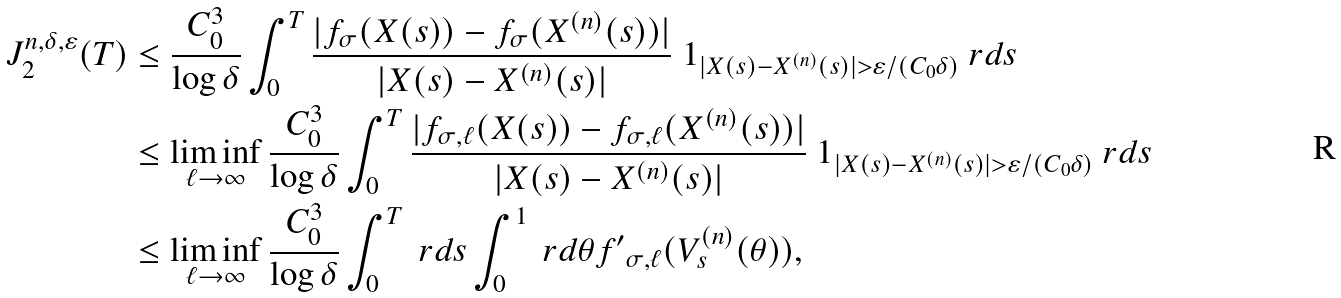<formula> <loc_0><loc_0><loc_500><loc_500>J _ { 2 } ^ { n , \delta , \varepsilon } ( T ) & \leq \frac { C ^ { 3 } _ { 0 } } { \log \delta } \int _ { 0 } ^ { T } \frac { | f _ { \sigma } ( X ( s ) ) - f _ { \sigma } ( X ^ { ( n ) } ( s ) ) | } { | X ( s ) - X ^ { ( n ) } ( s ) | } \ 1 _ { | X ( s ) - X ^ { ( n ) } ( s ) | > \varepsilon / ( C _ { 0 } \delta ) } \ r d s \\ & \leq \liminf _ { \ell \to \infty } \frac { C ^ { 3 } _ { 0 } } { \log \delta } \int _ { 0 } ^ { T } \frac { | f _ { \sigma , \ell } ( X ( s ) ) - f _ { \sigma , \ell } ( X ^ { ( n ) } ( s ) ) | } { | X ( s ) - X ^ { ( n ) } ( s ) | } \ 1 _ { | X ( s ) - X ^ { ( n ) } ( s ) | > \varepsilon / ( C _ { 0 } \delta ) } \ r d s \\ & \leq \liminf _ { \ell \to \infty } \frac { C _ { 0 } ^ { 3 } } { \log \delta } \int _ { 0 } ^ { T } \ r d s \int _ { 0 } ^ { 1 } \ r d \theta f { ^ { \prime } } _ { \sigma , \ell } ( V _ { s } ^ { ( n ) } ( \theta ) ) ,</formula> 